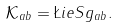<formula> <loc_0><loc_0><loc_500><loc_500>\mathcal { K } _ { a b } = \L i e S g _ { a b } .</formula> 